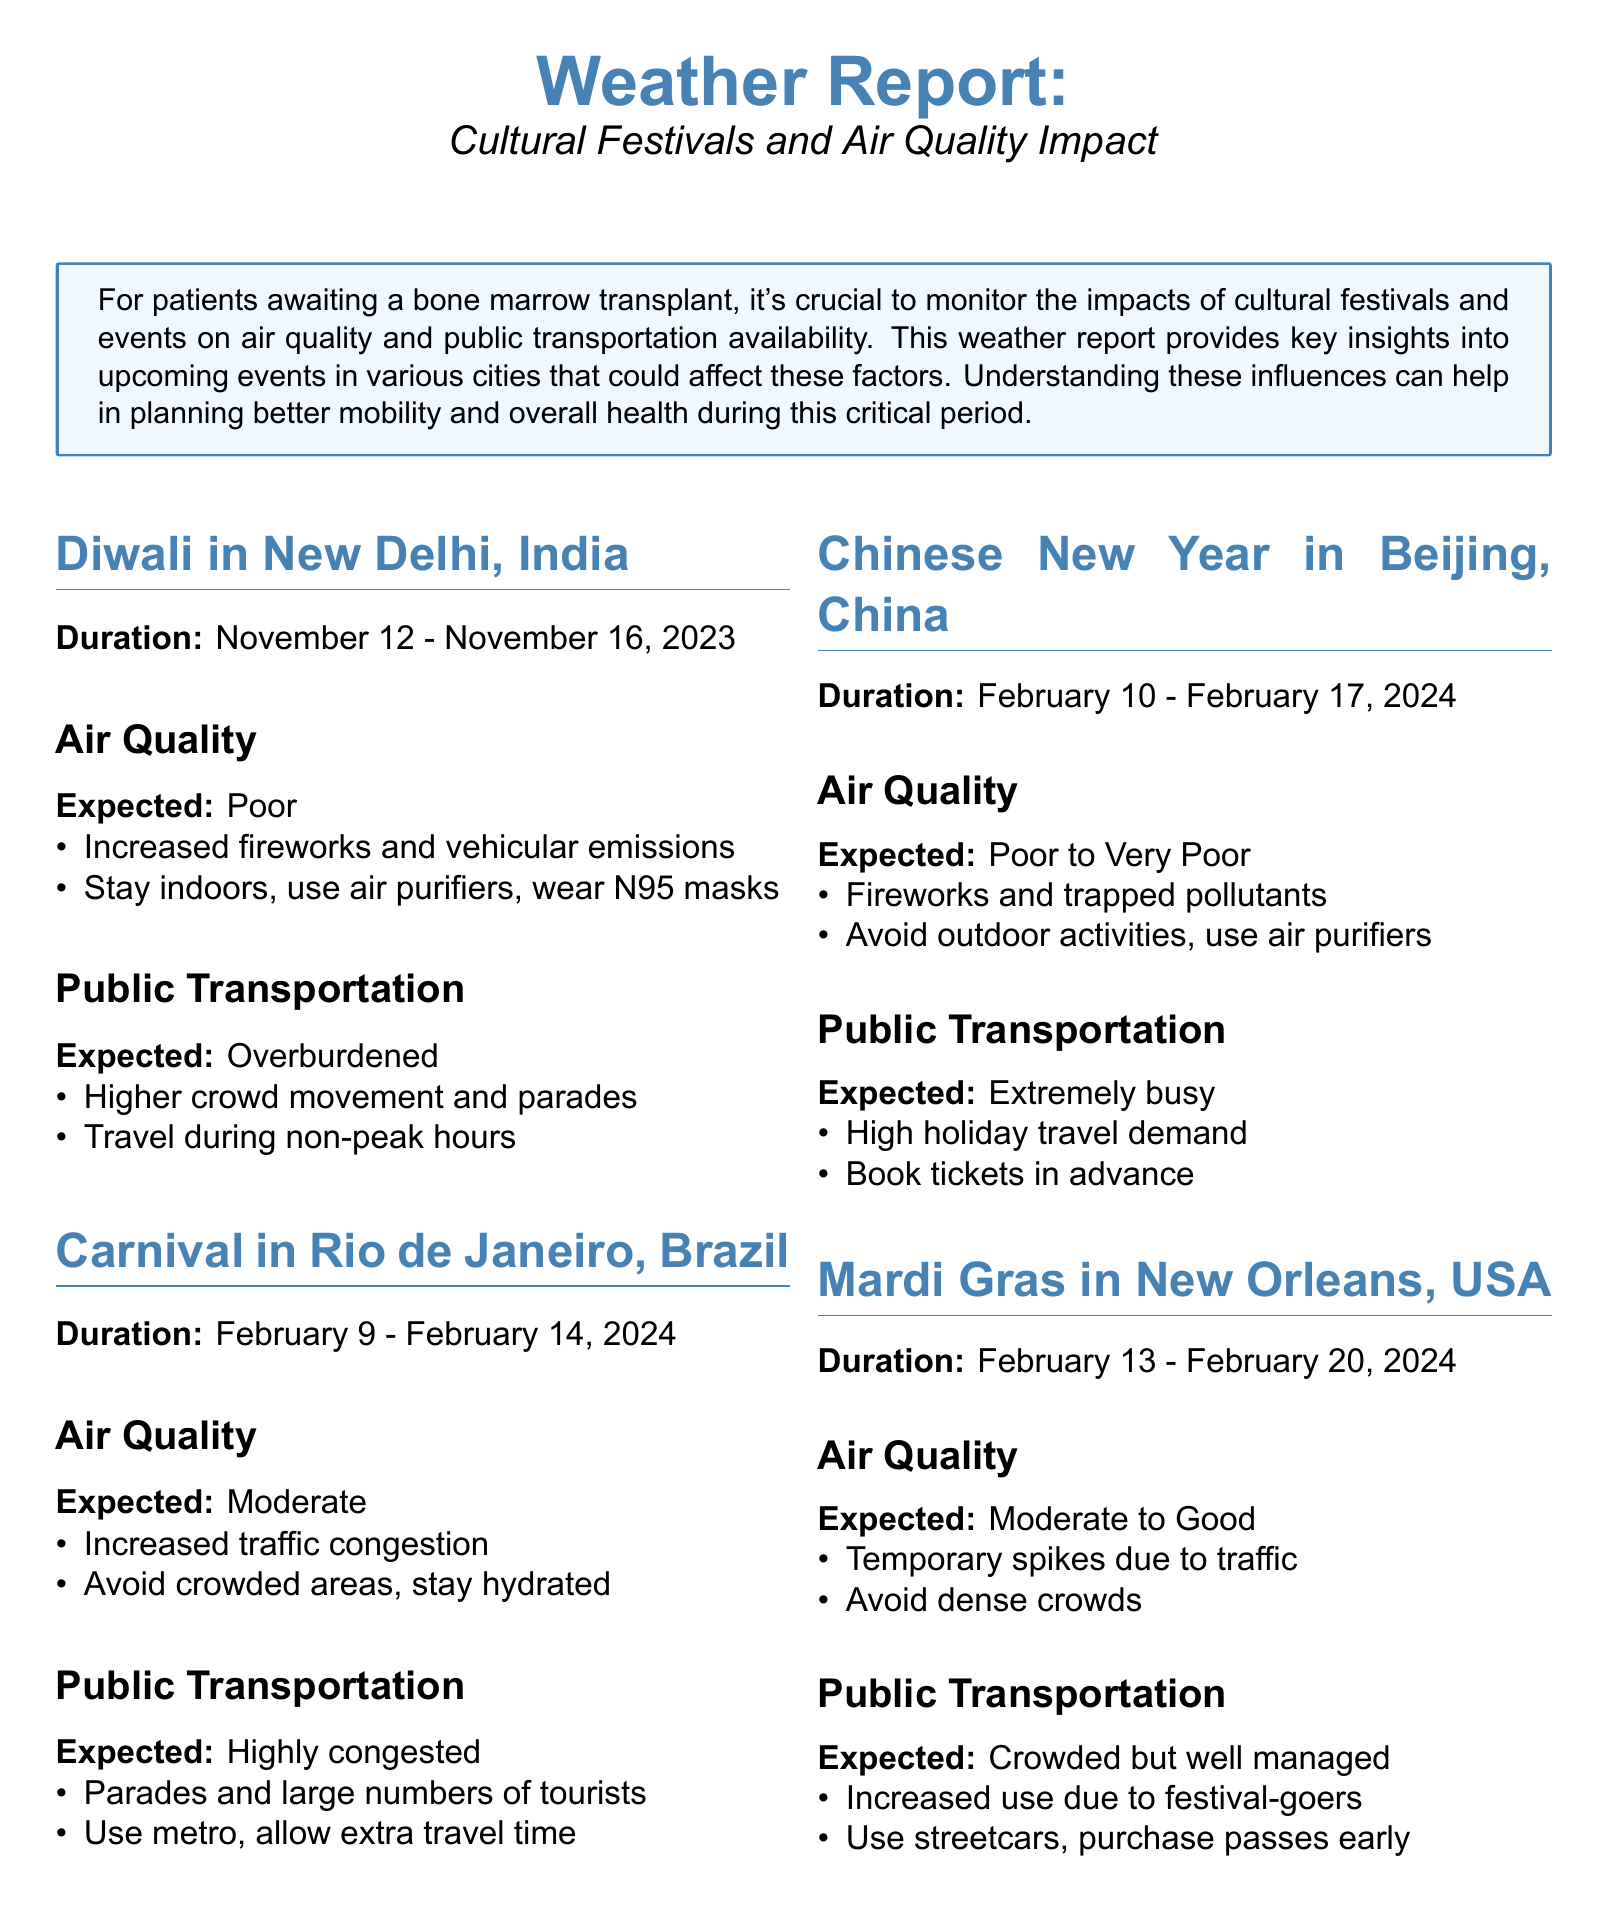what is the duration of Diwali in New Delhi? The document states the duration of Diwali as November 12 - November 16, 2023.
Answer: November 12 - November 16, 2023 what is the expected air quality during Carnival in Rio de Janeiro? The document indicates the expected air quality for Carnival in Rio de Janeiro as Moderate.
Answer: Moderate how long does Chinese New Year last in Beijing? The document lists the duration of Chinese New Year in Beijing as February 10 - February 17, 2024.
Answer: February 10 - February 17, 2024 what should be avoided due to poor air quality during Diwali? The document advises to stay indoors and use air purifiers during Diwali due to poor air quality.
Answer: Stay indoors, use air purifiers how is public transportation expected to be during Mardi Gras in New Orleans? The document states that public transportation is expected to be crowded but well managed during Mardi Gras.
Answer: Crowded but well managed what is a key recommendation for public transportation during Chinese New Year? The document recommends booking tickets in advance due to high holiday travel demand during Chinese New Year.
Answer: Book tickets in advance what causes poor air quality in Beijing during Chinese New Year? The document cites fireworks and trapped pollutants as causes for poor air quality in Beijing during Chinese New Year.
Answer: Fireworks and trapped pollutants what is the expected public transportation situation during Diwali in New Delhi? The document describes public transportation as overburdened during Diwali in New Delhi.
Answer: Overburdened 